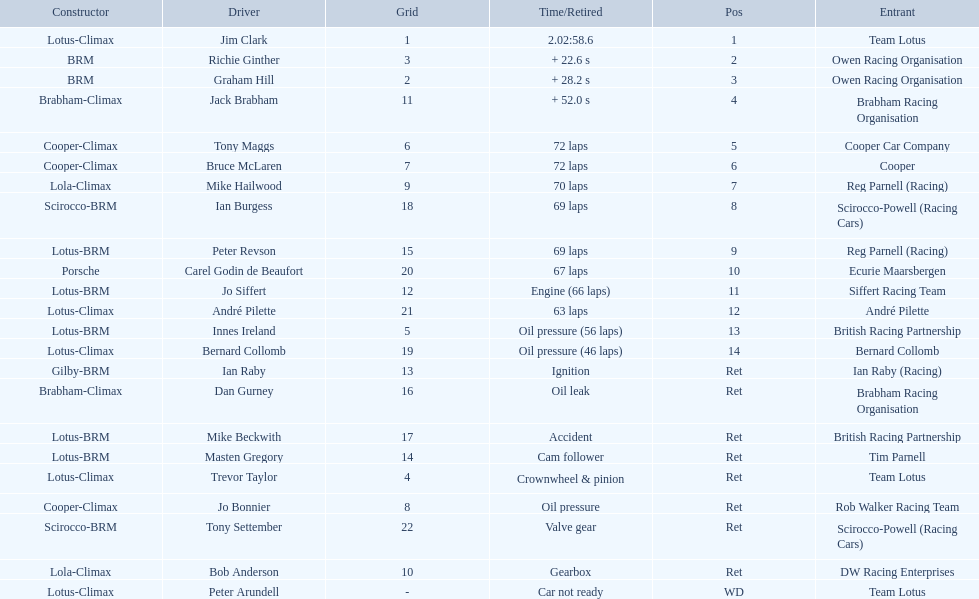Who were the drivers in the the 1963 international gold cup? Jim Clark, Richie Ginther, Graham Hill, Jack Brabham, Tony Maggs, Bruce McLaren, Mike Hailwood, Ian Burgess, Peter Revson, Carel Godin de Beaufort, Jo Siffert, André Pilette, Innes Ireland, Bernard Collomb, Ian Raby, Dan Gurney, Mike Beckwith, Masten Gregory, Trevor Taylor, Jo Bonnier, Tony Settember, Bob Anderson, Peter Arundell. Which drivers drove a cooper-climax car? Tony Maggs, Bruce McLaren, Jo Bonnier. What did these drivers place? 5, 6, Ret. What was the best placing position? 5. Who was the driver with this placing? Tony Maggs. 